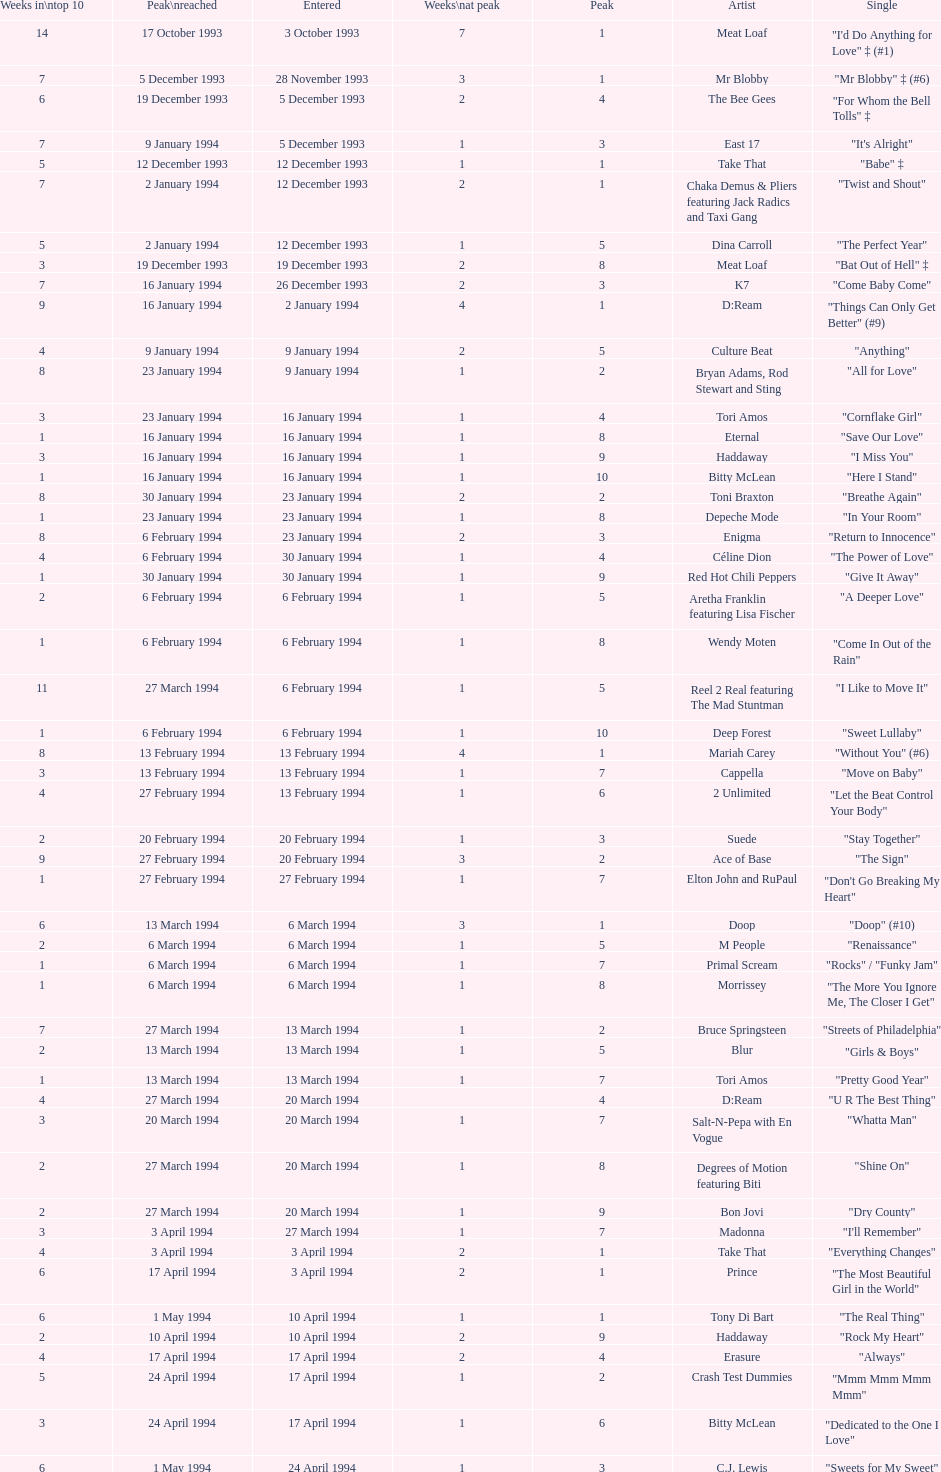This song released by celine dion spent 17 weeks on the uk singles chart in 1994, which one was it? "Think Twice". 